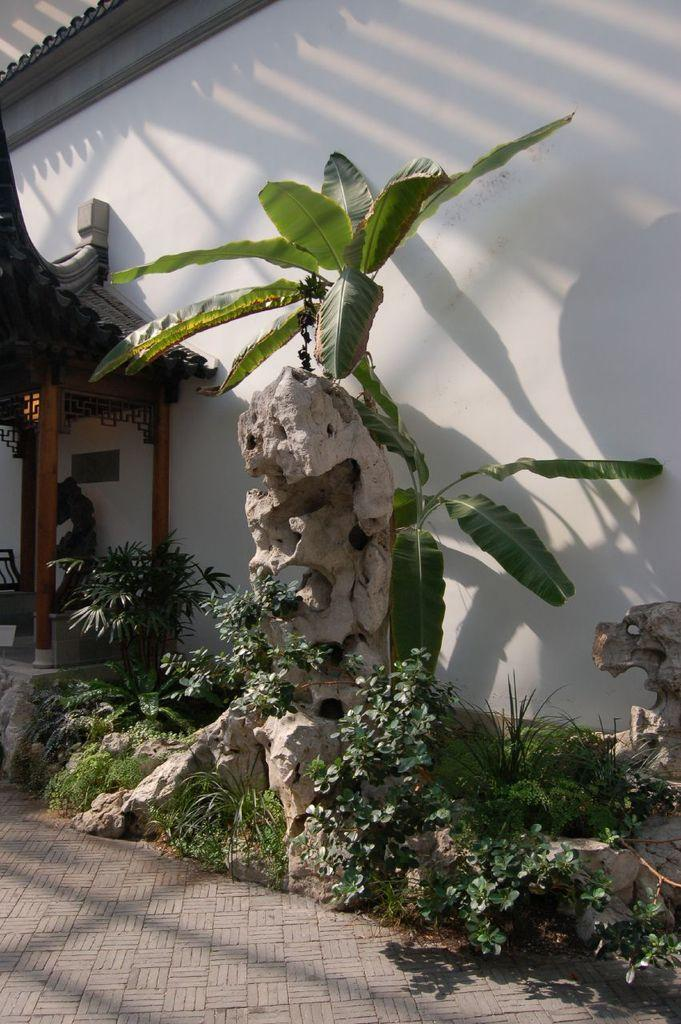What type of vegetation can be seen in the image? There are plants and grass in the image. What other natural elements are present in the image? There are rocks in the image. What type of background can be seen in the image? There is a white color wall in the image. What man-made object can be seen in the image? There is a wooden object in the image. How many volleyballs are visible in the image? There are no volleyballs present in the image. What type of cheese is being stored in the wooden object in the image? There is no cheese or any food item mentioned in the image; it only contains a wooden object. 